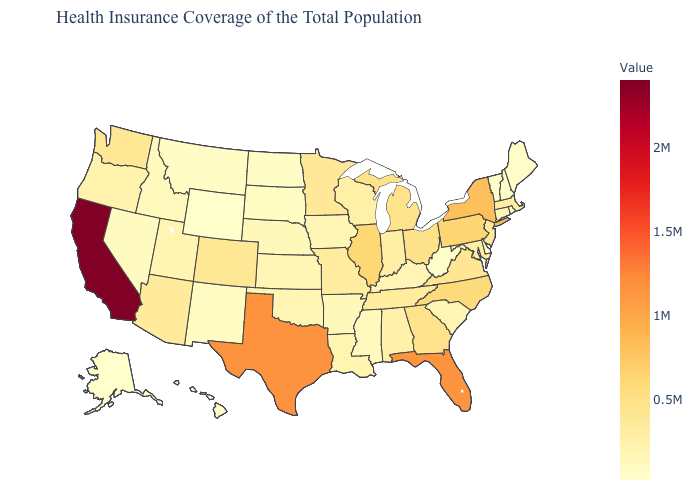Among the states that border Oregon , does Nevada have the lowest value?
Write a very short answer. Yes. Is the legend a continuous bar?
Be succinct. Yes. Among the states that border Virginia , which have the lowest value?
Give a very brief answer. West Virginia. Does Colorado have a lower value than Texas?
Concise answer only. Yes. Among the states that border New Jersey , which have the highest value?
Be succinct. New York. Is the legend a continuous bar?
Keep it brief. Yes. 